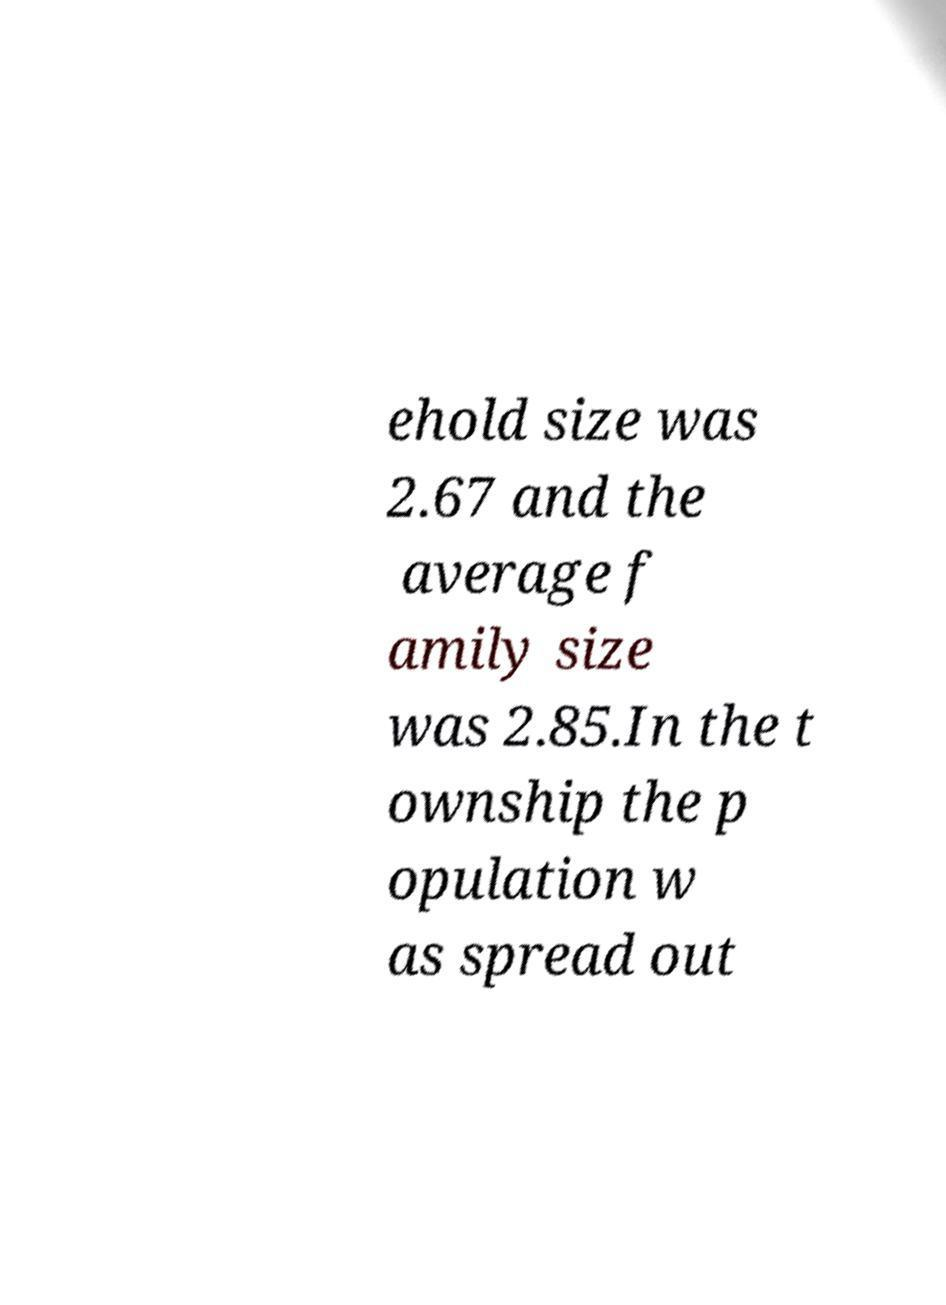I need the written content from this picture converted into text. Can you do that? ehold size was 2.67 and the average f amily size was 2.85.In the t ownship the p opulation w as spread out 